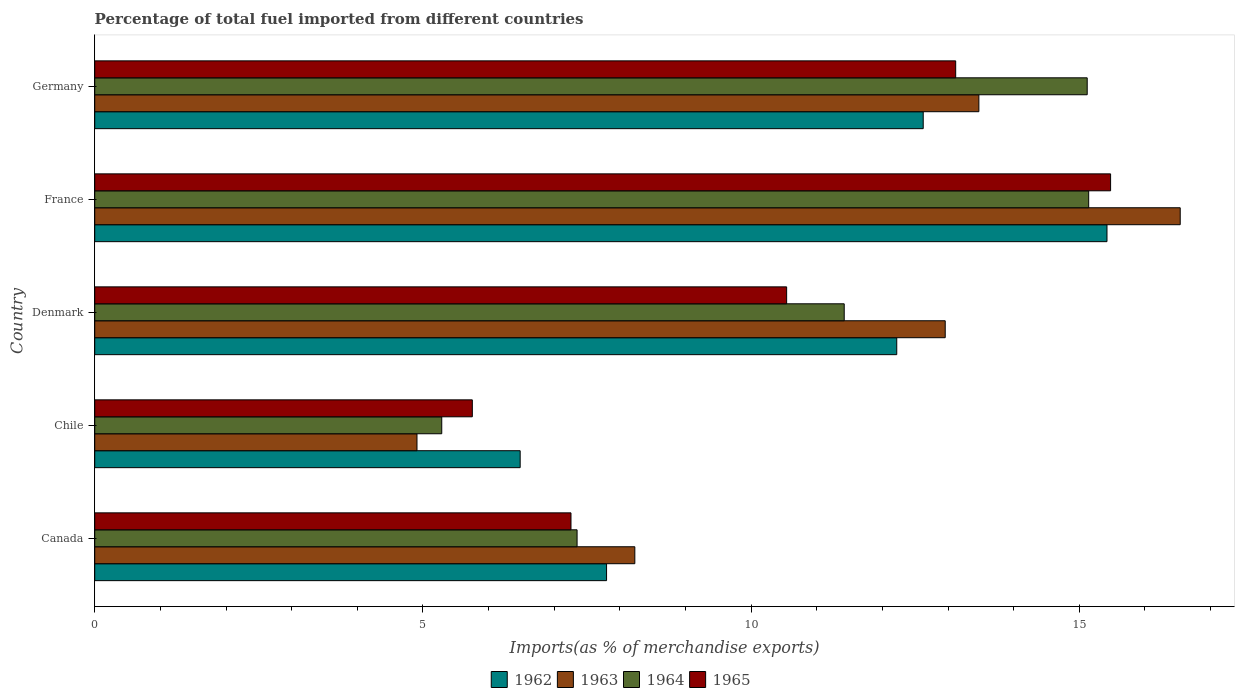How many different coloured bars are there?
Offer a very short reply. 4. Are the number of bars per tick equal to the number of legend labels?
Give a very brief answer. Yes. What is the label of the 2nd group of bars from the top?
Make the answer very short. France. In how many cases, is the number of bars for a given country not equal to the number of legend labels?
Provide a succinct answer. 0. What is the percentage of imports to different countries in 1965 in Canada?
Keep it short and to the point. 7.26. Across all countries, what is the maximum percentage of imports to different countries in 1963?
Make the answer very short. 16.54. Across all countries, what is the minimum percentage of imports to different countries in 1963?
Offer a very short reply. 4.91. In which country was the percentage of imports to different countries in 1964 maximum?
Offer a very short reply. France. In which country was the percentage of imports to different countries in 1964 minimum?
Give a very brief answer. Chile. What is the total percentage of imports to different countries in 1963 in the graph?
Your answer should be very brief. 56.1. What is the difference between the percentage of imports to different countries in 1963 in Chile and that in France?
Make the answer very short. -11.63. What is the difference between the percentage of imports to different countries in 1965 in Denmark and the percentage of imports to different countries in 1963 in Canada?
Keep it short and to the point. 2.31. What is the average percentage of imports to different countries in 1964 per country?
Ensure brevity in your answer.  10.86. What is the difference between the percentage of imports to different countries in 1964 and percentage of imports to different countries in 1962 in Germany?
Offer a terse response. 2.5. What is the ratio of the percentage of imports to different countries in 1964 in Chile to that in Germany?
Your response must be concise. 0.35. Is the percentage of imports to different countries in 1965 in Chile less than that in Denmark?
Your answer should be very brief. Yes. What is the difference between the highest and the second highest percentage of imports to different countries in 1965?
Give a very brief answer. 2.36. What is the difference between the highest and the lowest percentage of imports to different countries in 1964?
Make the answer very short. 9.86. What does the 2nd bar from the top in Germany represents?
Keep it short and to the point. 1964. What does the 3rd bar from the bottom in Denmark represents?
Give a very brief answer. 1964. What is the difference between two consecutive major ticks on the X-axis?
Ensure brevity in your answer.  5. Are the values on the major ticks of X-axis written in scientific E-notation?
Ensure brevity in your answer.  No. Where does the legend appear in the graph?
Offer a terse response. Bottom center. How many legend labels are there?
Make the answer very short. 4. What is the title of the graph?
Your response must be concise. Percentage of total fuel imported from different countries. Does "1960" appear as one of the legend labels in the graph?
Offer a very short reply. No. What is the label or title of the X-axis?
Provide a short and direct response. Imports(as % of merchandise exports). What is the Imports(as % of merchandise exports) of 1962 in Canada?
Provide a succinct answer. 7.8. What is the Imports(as % of merchandise exports) in 1963 in Canada?
Make the answer very short. 8.23. What is the Imports(as % of merchandise exports) of 1964 in Canada?
Provide a short and direct response. 7.35. What is the Imports(as % of merchandise exports) in 1965 in Canada?
Your answer should be very brief. 7.26. What is the Imports(as % of merchandise exports) of 1962 in Chile?
Offer a terse response. 6.48. What is the Imports(as % of merchandise exports) in 1963 in Chile?
Ensure brevity in your answer.  4.91. What is the Imports(as % of merchandise exports) of 1964 in Chile?
Offer a very short reply. 5.29. What is the Imports(as % of merchandise exports) in 1965 in Chile?
Make the answer very short. 5.75. What is the Imports(as % of merchandise exports) of 1962 in Denmark?
Provide a short and direct response. 12.22. What is the Imports(as % of merchandise exports) of 1963 in Denmark?
Provide a short and direct response. 12.96. What is the Imports(as % of merchandise exports) in 1964 in Denmark?
Your answer should be very brief. 11.42. What is the Imports(as % of merchandise exports) of 1965 in Denmark?
Make the answer very short. 10.54. What is the Imports(as % of merchandise exports) of 1962 in France?
Offer a terse response. 15.42. What is the Imports(as % of merchandise exports) of 1963 in France?
Give a very brief answer. 16.54. What is the Imports(as % of merchandise exports) of 1964 in France?
Give a very brief answer. 15.14. What is the Imports(as % of merchandise exports) in 1965 in France?
Provide a succinct answer. 15.48. What is the Imports(as % of merchandise exports) in 1962 in Germany?
Give a very brief answer. 12.62. What is the Imports(as % of merchandise exports) of 1963 in Germany?
Offer a very short reply. 13.47. What is the Imports(as % of merchandise exports) in 1964 in Germany?
Your answer should be very brief. 15.12. What is the Imports(as % of merchandise exports) in 1965 in Germany?
Make the answer very short. 13.12. Across all countries, what is the maximum Imports(as % of merchandise exports) of 1962?
Ensure brevity in your answer.  15.42. Across all countries, what is the maximum Imports(as % of merchandise exports) in 1963?
Your answer should be very brief. 16.54. Across all countries, what is the maximum Imports(as % of merchandise exports) of 1964?
Your answer should be very brief. 15.14. Across all countries, what is the maximum Imports(as % of merchandise exports) of 1965?
Your answer should be very brief. 15.48. Across all countries, what is the minimum Imports(as % of merchandise exports) in 1962?
Offer a very short reply. 6.48. Across all countries, what is the minimum Imports(as % of merchandise exports) in 1963?
Ensure brevity in your answer.  4.91. Across all countries, what is the minimum Imports(as % of merchandise exports) in 1964?
Keep it short and to the point. 5.29. Across all countries, what is the minimum Imports(as % of merchandise exports) in 1965?
Give a very brief answer. 5.75. What is the total Imports(as % of merchandise exports) in 1962 in the graph?
Your answer should be compact. 54.54. What is the total Imports(as % of merchandise exports) of 1963 in the graph?
Give a very brief answer. 56.1. What is the total Imports(as % of merchandise exports) of 1964 in the graph?
Ensure brevity in your answer.  54.32. What is the total Imports(as % of merchandise exports) of 1965 in the graph?
Your answer should be compact. 52.14. What is the difference between the Imports(as % of merchandise exports) of 1962 in Canada and that in Chile?
Ensure brevity in your answer.  1.32. What is the difference between the Imports(as % of merchandise exports) in 1963 in Canada and that in Chile?
Keep it short and to the point. 3.32. What is the difference between the Imports(as % of merchandise exports) of 1964 in Canada and that in Chile?
Provide a short and direct response. 2.06. What is the difference between the Imports(as % of merchandise exports) in 1965 in Canada and that in Chile?
Make the answer very short. 1.5. What is the difference between the Imports(as % of merchandise exports) in 1962 in Canada and that in Denmark?
Your answer should be compact. -4.42. What is the difference between the Imports(as % of merchandise exports) in 1963 in Canada and that in Denmark?
Your answer should be compact. -4.73. What is the difference between the Imports(as % of merchandise exports) of 1964 in Canada and that in Denmark?
Your response must be concise. -4.07. What is the difference between the Imports(as % of merchandise exports) in 1965 in Canada and that in Denmark?
Give a very brief answer. -3.29. What is the difference between the Imports(as % of merchandise exports) in 1962 in Canada and that in France?
Provide a short and direct response. -7.62. What is the difference between the Imports(as % of merchandise exports) in 1963 in Canada and that in France?
Your response must be concise. -8.31. What is the difference between the Imports(as % of merchandise exports) of 1964 in Canada and that in France?
Your answer should be very brief. -7.79. What is the difference between the Imports(as % of merchandise exports) in 1965 in Canada and that in France?
Ensure brevity in your answer.  -8.22. What is the difference between the Imports(as % of merchandise exports) of 1962 in Canada and that in Germany?
Offer a terse response. -4.82. What is the difference between the Imports(as % of merchandise exports) in 1963 in Canada and that in Germany?
Ensure brevity in your answer.  -5.24. What is the difference between the Imports(as % of merchandise exports) of 1964 in Canada and that in Germany?
Your response must be concise. -7.77. What is the difference between the Imports(as % of merchandise exports) in 1965 in Canada and that in Germany?
Your answer should be compact. -5.86. What is the difference between the Imports(as % of merchandise exports) in 1962 in Chile and that in Denmark?
Your answer should be very brief. -5.74. What is the difference between the Imports(as % of merchandise exports) of 1963 in Chile and that in Denmark?
Provide a short and direct response. -8.05. What is the difference between the Imports(as % of merchandise exports) in 1964 in Chile and that in Denmark?
Offer a terse response. -6.13. What is the difference between the Imports(as % of merchandise exports) of 1965 in Chile and that in Denmark?
Give a very brief answer. -4.79. What is the difference between the Imports(as % of merchandise exports) of 1962 in Chile and that in France?
Make the answer very short. -8.94. What is the difference between the Imports(as % of merchandise exports) in 1963 in Chile and that in France?
Make the answer very short. -11.63. What is the difference between the Imports(as % of merchandise exports) of 1964 in Chile and that in France?
Provide a succinct answer. -9.86. What is the difference between the Imports(as % of merchandise exports) in 1965 in Chile and that in France?
Your answer should be compact. -9.72. What is the difference between the Imports(as % of merchandise exports) of 1962 in Chile and that in Germany?
Your answer should be very brief. -6.14. What is the difference between the Imports(as % of merchandise exports) in 1963 in Chile and that in Germany?
Keep it short and to the point. -8.56. What is the difference between the Imports(as % of merchandise exports) of 1964 in Chile and that in Germany?
Give a very brief answer. -9.83. What is the difference between the Imports(as % of merchandise exports) in 1965 in Chile and that in Germany?
Keep it short and to the point. -7.36. What is the difference between the Imports(as % of merchandise exports) of 1962 in Denmark and that in France?
Ensure brevity in your answer.  -3.2. What is the difference between the Imports(as % of merchandise exports) in 1963 in Denmark and that in France?
Provide a succinct answer. -3.58. What is the difference between the Imports(as % of merchandise exports) of 1964 in Denmark and that in France?
Your answer should be very brief. -3.72. What is the difference between the Imports(as % of merchandise exports) of 1965 in Denmark and that in France?
Make the answer very short. -4.94. What is the difference between the Imports(as % of merchandise exports) in 1962 in Denmark and that in Germany?
Offer a very short reply. -0.4. What is the difference between the Imports(as % of merchandise exports) in 1963 in Denmark and that in Germany?
Provide a succinct answer. -0.51. What is the difference between the Imports(as % of merchandise exports) in 1964 in Denmark and that in Germany?
Offer a terse response. -3.7. What is the difference between the Imports(as % of merchandise exports) in 1965 in Denmark and that in Germany?
Ensure brevity in your answer.  -2.58. What is the difference between the Imports(as % of merchandise exports) of 1962 in France and that in Germany?
Offer a very short reply. 2.8. What is the difference between the Imports(as % of merchandise exports) in 1963 in France and that in Germany?
Give a very brief answer. 3.07. What is the difference between the Imports(as % of merchandise exports) of 1964 in France and that in Germany?
Ensure brevity in your answer.  0.02. What is the difference between the Imports(as % of merchandise exports) in 1965 in France and that in Germany?
Ensure brevity in your answer.  2.36. What is the difference between the Imports(as % of merchandise exports) in 1962 in Canada and the Imports(as % of merchandise exports) in 1963 in Chile?
Offer a terse response. 2.89. What is the difference between the Imports(as % of merchandise exports) of 1962 in Canada and the Imports(as % of merchandise exports) of 1964 in Chile?
Keep it short and to the point. 2.51. What is the difference between the Imports(as % of merchandise exports) of 1962 in Canada and the Imports(as % of merchandise exports) of 1965 in Chile?
Keep it short and to the point. 2.04. What is the difference between the Imports(as % of merchandise exports) of 1963 in Canada and the Imports(as % of merchandise exports) of 1964 in Chile?
Make the answer very short. 2.94. What is the difference between the Imports(as % of merchandise exports) in 1963 in Canada and the Imports(as % of merchandise exports) in 1965 in Chile?
Your answer should be very brief. 2.48. What is the difference between the Imports(as % of merchandise exports) of 1964 in Canada and the Imports(as % of merchandise exports) of 1965 in Chile?
Offer a very short reply. 1.6. What is the difference between the Imports(as % of merchandise exports) in 1962 in Canada and the Imports(as % of merchandise exports) in 1963 in Denmark?
Offer a terse response. -5.16. What is the difference between the Imports(as % of merchandise exports) of 1962 in Canada and the Imports(as % of merchandise exports) of 1964 in Denmark?
Provide a short and direct response. -3.62. What is the difference between the Imports(as % of merchandise exports) of 1962 in Canada and the Imports(as % of merchandise exports) of 1965 in Denmark?
Keep it short and to the point. -2.74. What is the difference between the Imports(as % of merchandise exports) of 1963 in Canada and the Imports(as % of merchandise exports) of 1964 in Denmark?
Offer a very short reply. -3.19. What is the difference between the Imports(as % of merchandise exports) of 1963 in Canada and the Imports(as % of merchandise exports) of 1965 in Denmark?
Ensure brevity in your answer.  -2.31. What is the difference between the Imports(as % of merchandise exports) of 1964 in Canada and the Imports(as % of merchandise exports) of 1965 in Denmark?
Keep it short and to the point. -3.19. What is the difference between the Imports(as % of merchandise exports) in 1962 in Canada and the Imports(as % of merchandise exports) in 1963 in France?
Provide a short and direct response. -8.74. What is the difference between the Imports(as % of merchandise exports) in 1962 in Canada and the Imports(as % of merchandise exports) in 1964 in France?
Offer a very short reply. -7.35. What is the difference between the Imports(as % of merchandise exports) of 1962 in Canada and the Imports(as % of merchandise exports) of 1965 in France?
Your answer should be compact. -7.68. What is the difference between the Imports(as % of merchandise exports) in 1963 in Canada and the Imports(as % of merchandise exports) in 1964 in France?
Offer a terse response. -6.91. What is the difference between the Imports(as % of merchandise exports) of 1963 in Canada and the Imports(as % of merchandise exports) of 1965 in France?
Provide a short and direct response. -7.25. What is the difference between the Imports(as % of merchandise exports) of 1964 in Canada and the Imports(as % of merchandise exports) of 1965 in France?
Your answer should be very brief. -8.13. What is the difference between the Imports(as % of merchandise exports) of 1962 in Canada and the Imports(as % of merchandise exports) of 1963 in Germany?
Offer a very short reply. -5.67. What is the difference between the Imports(as % of merchandise exports) in 1962 in Canada and the Imports(as % of merchandise exports) in 1964 in Germany?
Provide a short and direct response. -7.32. What is the difference between the Imports(as % of merchandise exports) in 1962 in Canada and the Imports(as % of merchandise exports) in 1965 in Germany?
Your answer should be compact. -5.32. What is the difference between the Imports(as % of merchandise exports) in 1963 in Canada and the Imports(as % of merchandise exports) in 1964 in Germany?
Offer a very short reply. -6.89. What is the difference between the Imports(as % of merchandise exports) in 1963 in Canada and the Imports(as % of merchandise exports) in 1965 in Germany?
Keep it short and to the point. -4.89. What is the difference between the Imports(as % of merchandise exports) in 1964 in Canada and the Imports(as % of merchandise exports) in 1965 in Germany?
Offer a very short reply. -5.77. What is the difference between the Imports(as % of merchandise exports) of 1962 in Chile and the Imports(as % of merchandise exports) of 1963 in Denmark?
Your answer should be compact. -6.48. What is the difference between the Imports(as % of merchandise exports) in 1962 in Chile and the Imports(as % of merchandise exports) in 1964 in Denmark?
Offer a very short reply. -4.94. What is the difference between the Imports(as % of merchandise exports) in 1962 in Chile and the Imports(as % of merchandise exports) in 1965 in Denmark?
Your response must be concise. -4.06. What is the difference between the Imports(as % of merchandise exports) of 1963 in Chile and the Imports(as % of merchandise exports) of 1964 in Denmark?
Offer a terse response. -6.51. What is the difference between the Imports(as % of merchandise exports) in 1963 in Chile and the Imports(as % of merchandise exports) in 1965 in Denmark?
Make the answer very short. -5.63. What is the difference between the Imports(as % of merchandise exports) in 1964 in Chile and the Imports(as % of merchandise exports) in 1965 in Denmark?
Make the answer very short. -5.25. What is the difference between the Imports(as % of merchandise exports) of 1962 in Chile and the Imports(as % of merchandise exports) of 1963 in France?
Keep it short and to the point. -10.06. What is the difference between the Imports(as % of merchandise exports) of 1962 in Chile and the Imports(as % of merchandise exports) of 1964 in France?
Keep it short and to the point. -8.66. What is the difference between the Imports(as % of merchandise exports) of 1962 in Chile and the Imports(as % of merchandise exports) of 1965 in France?
Your answer should be very brief. -9. What is the difference between the Imports(as % of merchandise exports) of 1963 in Chile and the Imports(as % of merchandise exports) of 1964 in France?
Offer a terse response. -10.23. What is the difference between the Imports(as % of merchandise exports) in 1963 in Chile and the Imports(as % of merchandise exports) in 1965 in France?
Keep it short and to the point. -10.57. What is the difference between the Imports(as % of merchandise exports) in 1964 in Chile and the Imports(as % of merchandise exports) in 1965 in France?
Keep it short and to the point. -10.19. What is the difference between the Imports(as % of merchandise exports) of 1962 in Chile and the Imports(as % of merchandise exports) of 1963 in Germany?
Offer a terse response. -6.99. What is the difference between the Imports(as % of merchandise exports) of 1962 in Chile and the Imports(as % of merchandise exports) of 1964 in Germany?
Offer a very short reply. -8.64. What is the difference between the Imports(as % of merchandise exports) of 1962 in Chile and the Imports(as % of merchandise exports) of 1965 in Germany?
Ensure brevity in your answer.  -6.64. What is the difference between the Imports(as % of merchandise exports) in 1963 in Chile and the Imports(as % of merchandise exports) in 1964 in Germany?
Your answer should be compact. -10.21. What is the difference between the Imports(as % of merchandise exports) of 1963 in Chile and the Imports(as % of merchandise exports) of 1965 in Germany?
Give a very brief answer. -8.21. What is the difference between the Imports(as % of merchandise exports) in 1964 in Chile and the Imports(as % of merchandise exports) in 1965 in Germany?
Provide a succinct answer. -7.83. What is the difference between the Imports(as % of merchandise exports) of 1962 in Denmark and the Imports(as % of merchandise exports) of 1963 in France?
Keep it short and to the point. -4.32. What is the difference between the Imports(as % of merchandise exports) in 1962 in Denmark and the Imports(as % of merchandise exports) in 1964 in France?
Ensure brevity in your answer.  -2.92. What is the difference between the Imports(as % of merchandise exports) of 1962 in Denmark and the Imports(as % of merchandise exports) of 1965 in France?
Keep it short and to the point. -3.26. What is the difference between the Imports(as % of merchandise exports) in 1963 in Denmark and the Imports(as % of merchandise exports) in 1964 in France?
Offer a very short reply. -2.19. What is the difference between the Imports(as % of merchandise exports) in 1963 in Denmark and the Imports(as % of merchandise exports) in 1965 in France?
Your answer should be compact. -2.52. What is the difference between the Imports(as % of merchandise exports) in 1964 in Denmark and the Imports(as % of merchandise exports) in 1965 in France?
Provide a succinct answer. -4.06. What is the difference between the Imports(as % of merchandise exports) in 1962 in Denmark and the Imports(as % of merchandise exports) in 1963 in Germany?
Ensure brevity in your answer.  -1.25. What is the difference between the Imports(as % of merchandise exports) of 1962 in Denmark and the Imports(as % of merchandise exports) of 1964 in Germany?
Provide a succinct answer. -2.9. What is the difference between the Imports(as % of merchandise exports) in 1962 in Denmark and the Imports(as % of merchandise exports) in 1965 in Germany?
Your answer should be compact. -0.9. What is the difference between the Imports(as % of merchandise exports) of 1963 in Denmark and the Imports(as % of merchandise exports) of 1964 in Germany?
Provide a succinct answer. -2.16. What is the difference between the Imports(as % of merchandise exports) in 1963 in Denmark and the Imports(as % of merchandise exports) in 1965 in Germany?
Offer a very short reply. -0.16. What is the difference between the Imports(as % of merchandise exports) in 1964 in Denmark and the Imports(as % of merchandise exports) in 1965 in Germany?
Keep it short and to the point. -1.7. What is the difference between the Imports(as % of merchandise exports) of 1962 in France and the Imports(as % of merchandise exports) of 1963 in Germany?
Provide a short and direct response. 1.95. What is the difference between the Imports(as % of merchandise exports) in 1962 in France and the Imports(as % of merchandise exports) in 1964 in Germany?
Your answer should be very brief. 0.3. What is the difference between the Imports(as % of merchandise exports) of 1962 in France and the Imports(as % of merchandise exports) of 1965 in Germany?
Your answer should be compact. 2.31. What is the difference between the Imports(as % of merchandise exports) of 1963 in France and the Imports(as % of merchandise exports) of 1964 in Germany?
Your answer should be compact. 1.42. What is the difference between the Imports(as % of merchandise exports) of 1963 in France and the Imports(as % of merchandise exports) of 1965 in Germany?
Your answer should be compact. 3.42. What is the difference between the Imports(as % of merchandise exports) of 1964 in France and the Imports(as % of merchandise exports) of 1965 in Germany?
Ensure brevity in your answer.  2.03. What is the average Imports(as % of merchandise exports) of 1962 per country?
Your answer should be very brief. 10.91. What is the average Imports(as % of merchandise exports) in 1963 per country?
Give a very brief answer. 11.22. What is the average Imports(as % of merchandise exports) in 1964 per country?
Make the answer very short. 10.86. What is the average Imports(as % of merchandise exports) in 1965 per country?
Your answer should be compact. 10.43. What is the difference between the Imports(as % of merchandise exports) of 1962 and Imports(as % of merchandise exports) of 1963 in Canada?
Your response must be concise. -0.43. What is the difference between the Imports(as % of merchandise exports) of 1962 and Imports(as % of merchandise exports) of 1964 in Canada?
Provide a short and direct response. 0.45. What is the difference between the Imports(as % of merchandise exports) in 1962 and Imports(as % of merchandise exports) in 1965 in Canada?
Keep it short and to the point. 0.54. What is the difference between the Imports(as % of merchandise exports) of 1963 and Imports(as % of merchandise exports) of 1964 in Canada?
Make the answer very short. 0.88. What is the difference between the Imports(as % of merchandise exports) in 1963 and Imports(as % of merchandise exports) in 1965 in Canada?
Your answer should be very brief. 0.97. What is the difference between the Imports(as % of merchandise exports) in 1964 and Imports(as % of merchandise exports) in 1965 in Canada?
Give a very brief answer. 0.09. What is the difference between the Imports(as % of merchandise exports) of 1962 and Imports(as % of merchandise exports) of 1963 in Chile?
Ensure brevity in your answer.  1.57. What is the difference between the Imports(as % of merchandise exports) in 1962 and Imports(as % of merchandise exports) in 1964 in Chile?
Offer a very short reply. 1.19. What is the difference between the Imports(as % of merchandise exports) in 1962 and Imports(as % of merchandise exports) in 1965 in Chile?
Make the answer very short. 0.73. What is the difference between the Imports(as % of merchandise exports) in 1963 and Imports(as % of merchandise exports) in 1964 in Chile?
Ensure brevity in your answer.  -0.38. What is the difference between the Imports(as % of merchandise exports) of 1963 and Imports(as % of merchandise exports) of 1965 in Chile?
Ensure brevity in your answer.  -0.84. What is the difference between the Imports(as % of merchandise exports) of 1964 and Imports(as % of merchandise exports) of 1965 in Chile?
Your response must be concise. -0.47. What is the difference between the Imports(as % of merchandise exports) in 1962 and Imports(as % of merchandise exports) in 1963 in Denmark?
Give a very brief answer. -0.74. What is the difference between the Imports(as % of merchandise exports) in 1962 and Imports(as % of merchandise exports) in 1964 in Denmark?
Keep it short and to the point. 0.8. What is the difference between the Imports(as % of merchandise exports) of 1962 and Imports(as % of merchandise exports) of 1965 in Denmark?
Your response must be concise. 1.68. What is the difference between the Imports(as % of merchandise exports) in 1963 and Imports(as % of merchandise exports) in 1964 in Denmark?
Provide a short and direct response. 1.54. What is the difference between the Imports(as % of merchandise exports) in 1963 and Imports(as % of merchandise exports) in 1965 in Denmark?
Your answer should be very brief. 2.42. What is the difference between the Imports(as % of merchandise exports) in 1964 and Imports(as % of merchandise exports) in 1965 in Denmark?
Ensure brevity in your answer.  0.88. What is the difference between the Imports(as % of merchandise exports) in 1962 and Imports(as % of merchandise exports) in 1963 in France?
Offer a terse response. -1.12. What is the difference between the Imports(as % of merchandise exports) in 1962 and Imports(as % of merchandise exports) in 1964 in France?
Your answer should be compact. 0.28. What is the difference between the Imports(as % of merchandise exports) of 1962 and Imports(as % of merchandise exports) of 1965 in France?
Offer a terse response. -0.05. What is the difference between the Imports(as % of merchandise exports) in 1963 and Imports(as % of merchandise exports) in 1964 in France?
Provide a succinct answer. 1.39. What is the difference between the Imports(as % of merchandise exports) in 1963 and Imports(as % of merchandise exports) in 1965 in France?
Provide a succinct answer. 1.06. What is the difference between the Imports(as % of merchandise exports) of 1964 and Imports(as % of merchandise exports) of 1965 in France?
Offer a very short reply. -0.33. What is the difference between the Imports(as % of merchandise exports) in 1962 and Imports(as % of merchandise exports) in 1963 in Germany?
Provide a short and direct response. -0.85. What is the difference between the Imports(as % of merchandise exports) of 1962 and Imports(as % of merchandise exports) of 1964 in Germany?
Offer a very short reply. -2.5. What is the difference between the Imports(as % of merchandise exports) of 1962 and Imports(as % of merchandise exports) of 1965 in Germany?
Your answer should be very brief. -0.49. What is the difference between the Imports(as % of merchandise exports) in 1963 and Imports(as % of merchandise exports) in 1964 in Germany?
Offer a terse response. -1.65. What is the difference between the Imports(as % of merchandise exports) in 1963 and Imports(as % of merchandise exports) in 1965 in Germany?
Offer a terse response. 0.35. What is the difference between the Imports(as % of merchandise exports) of 1964 and Imports(as % of merchandise exports) of 1965 in Germany?
Your response must be concise. 2. What is the ratio of the Imports(as % of merchandise exports) in 1962 in Canada to that in Chile?
Your answer should be very brief. 1.2. What is the ratio of the Imports(as % of merchandise exports) of 1963 in Canada to that in Chile?
Provide a short and direct response. 1.68. What is the ratio of the Imports(as % of merchandise exports) in 1964 in Canada to that in Chile?
Offer a terse response. 1.39. What is the ratio of the Imports(as % of merchandise exports) in 1965 in Canada to that in Chile?
Make the answer very short. 1.26. What is the ratio of the Imports(as % of merchandise exports) in 1962 in Canada to that in Denmark?
Ensure brevity in your answer.  0.64. What is the ratio of the Imports(as % of merchandise exports) of 1963 in Canada to that in Denmark?
Offer a very short reply. 0.64. What is the ratio of the Imports(as % of merchandise exports) in 1964 in Canada to that in Denmark?
Your answer should be compact. 0.64. What is the ratio of the Imports(as % of merchandise exports) in 1965 in Canada to that in Denmark?
Make the answer very short. 0.69. What is the ratio of the Imports(as % of merchandise exports) of 1962 in Canada to that in France?
Provide a short and direct response. 0.51. What is the ratio of the Imports(as % of merchandise exports) in 1963 in Canada to that in France?
Make the answer very short. 0.5. What is the ratio of the Imports(as % of merchandise exports) in 1964 in Canada to that in France?
Your answer should be very brief. 0.49. What is the ratio of the Imports(as % of merchandise exports) in 1965 in Canada to that in France?
Ensure brevity in your answer.  0.47. What is the ratio of the Imports(as % of merchandise exports) in 1962 in Canada to that in Germany?
Provide a short and direct response. 0.62. What is the ratio of the Imports(as % of merchandise exports) of 1963 in Canada to that in Germany?
Give a very brief answer. 0.61. What is the ratio of the Imports(as % of merchandise exports) in 1964 in Canada to that in Germany?
Provide a short and direct response. 0.49. What is the ratio of the Imports(as % of merchandise exports) of 1965 in Canada to that in Germany?
Your answer should be very brief. 0.55. What is the ratio of the Imports(as % of merchandise exports) of 1962 in Chile to that in Denmark?
Give a very brief answer. 0.53. What is the ratio of the Imports(as % of merchandise exports) of 1963 in Chile to that in Denmark?
Give a very brief answer. 0.38. What is the ratio of the Imports(as % of merchandise exports) of 1964 in Chile to that in Denmark?
Offer a very short reply. 0.46. What is the ratio of the Imports(as % of merchandise exports) of 1965 in Chile to that in Denmark?
Offer a very short reply. 0.55. What is the ratio of the Imports(as % of merchandise exports) of 1962 in Chile to that in France?
Offer a terse response. 0.42. What is the ratio of the Imports(as % of merchandise exports) in 1963 in Chile to that in France?
Your response must be concise. 0.3. What is the ratio of the Imports(as % of merchandise exports) of 1964 in Chile to that in France?
Your response must be concise. 0.35. What is the ratio of the Imports(as % of merchandise exports) of 1965 in Chile to that in France?
Your answer should be very brief. 0.37. What is the ratio of the Imports(as % of merchandise exports) in 1962 in Chile to that in Germany?
Offer a very short reply. 0.51. What is the ratio of the Imports(as % of merchandise exports) of 1963 in Chile to that in Germany?
Offer a terse response. 0.36. What is the ratio of the Imports(as % of merchandise exports) of 1964 in Chile to that in Germany?
Provide a short and direct response. 0.35. What is the ratio of the Imports(as % of merchandise exports) of 1965 in Chile to that in Germany?
Your answer should be compact. 0.44. What is the ratio of the Imports(as % of merchandise exports) in 1962 in Denmark to that in France?
Provide a short and direct response. 0.79. What is the ratio of the Imports(as % of merchandise exports) in 1963 in Denmark to that in France?
Your answer should be compact. 0.78. What is the ratio of the Imports(as % of merchandise exports) of 1964 in Denmark to that in France?
Your response must be concise. 0.75. What is the ratio of the Imports(as % of merchandise exports) of 1965 in Denmark to that in France?
Your answer should be very brief. 0.68. What is the ratio of the Imports(as % of merchandise exports) in 1962 in Denmark to that in Germany?
Offer a very short reply. 0.97. What is the ratio of the Imports(as % of merchandise exports) in 1963 in Denmark to that in Germany?
Provide a short and direct response. 0.96. What is the ratio of the Imports(as % of merchandise exports) of 1964 in Denmark to that in Germany?
Ensure brevity in your answer.  0.76. What is the ratio of the Imports(as % of merchandise exports) in 1965 in Denmark to that in Germany?
Offer a terse response. 0.8. What is the ratio of the Imports(as % of merchandise exports) in 1962 in France to that in Germany?
Your answer should be very brief. 1.22. What is the ratio of the Imports(as % of merchandise exports) in 1963 in France to that in Germany?
Ensure brevity in your answer.  1.23. What is the ratio of the Imports(as % of merchandise exports) in 1964 in France to that in Germany?
Keep it short and to the point. 1. What is the ratio of the Imports(as % of merchandise exports) of 1965 in France to that in Germany?
Make the answer very short. 1.18. What is the difference between the highest and the second highest Imports(as % of merchandise exports) of 1962?
Provide a succinct answer. 2.8. What is the difference between the highest and the second highest Imports(as % of merchandise exports) in 1963?
Give a very brief answer. 3.07. What is the difference between the highest and the second highest Imports(as % of merchandise exports) in 1964?
Offer a very short reply. 0.02. What is the difference between the highest and the second highest Imports(as % of merchandise exports) of 1965?
Keep it short and to the point. 2.36. What is the difference between the highest and the lowest Imports(as % of merchandise exports) of 1962?
Ensure brevity in your answer.  8.94. What is the difference between the highest and the lowest Imports(as % of merchandise exports) of 1963?
Give a very brief answer. 11.63. What is the difference between the highest and the lowest Imports(as % of merchandise exports) of 1964?
Your answer should be compact. 9.86. What is the difference between the highest and the lowest Imports(as % of merchandise exports) in 1965?
Your answer should be very brief. 9.72. 